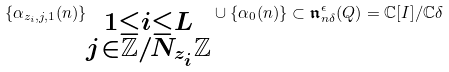<formula> <loc_0><loc_0><loc_500><loc_500>\{ \alpha _ { z _ { i } , j , 1 } ( n ) \} _ { \substack { 1 \leq i \leq L \\ j \in \mathbb { Z } / N _ { z _ { i } } \mathbb { Z } } } \cup \{ \alpha _ { 0 } ( n ) \} \subset \mathfrak { n } ^ { \epsilon } _ { n \delta } ( Q ) = \mathbb { C } [ I ] / \mathbb { C } \delta</formula> 